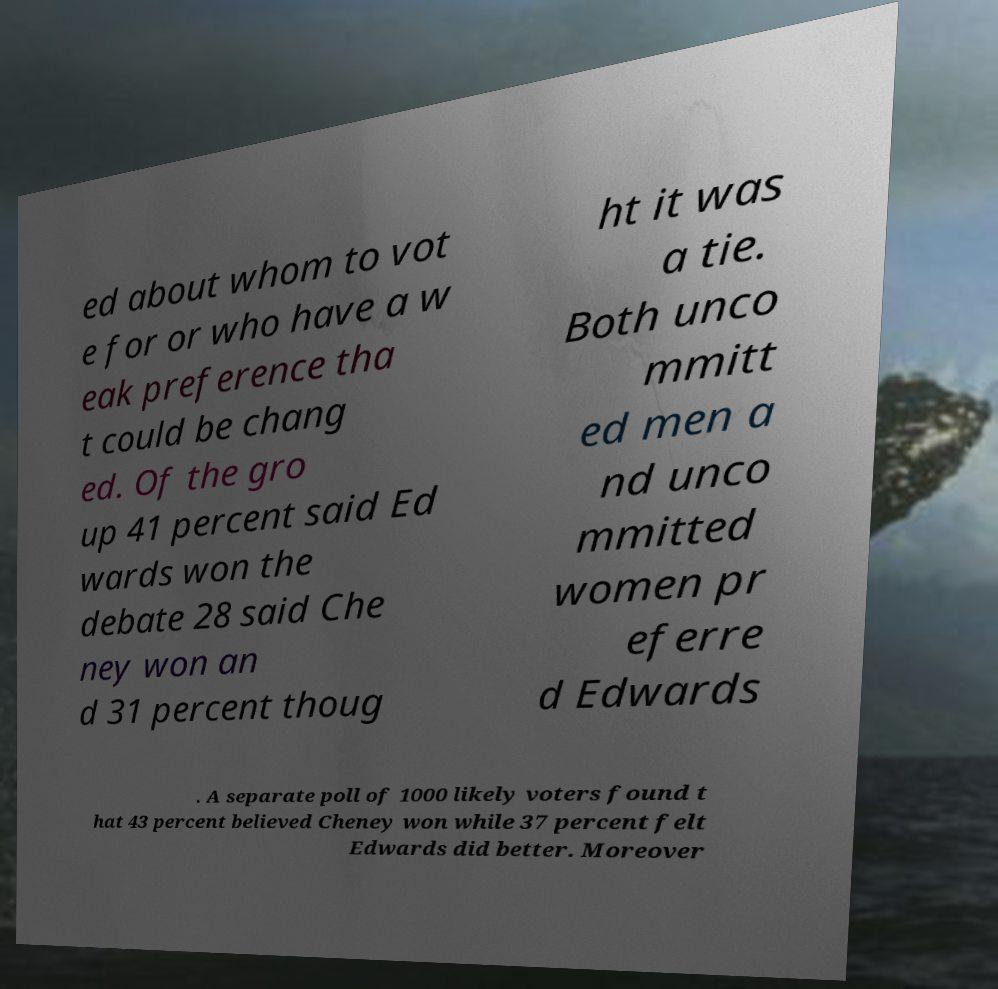What messages or text are displayed in this image? I need them in a readable, typed format. ed about whom to vot e for or who have a w eak preference tha t could be chang ed. Of the gro up 41 percent said Ed wards won the debate 28 said Che ney won an d 31 percent thoug ht it was a tie. Both unco mmitt ed men a nd unco mmitted women pr eferre d Edwards . A separate poll of 1000 likely voters found t hat 43 percent believed Cheney won while 37 percent felt Edwards did better. Moreover 